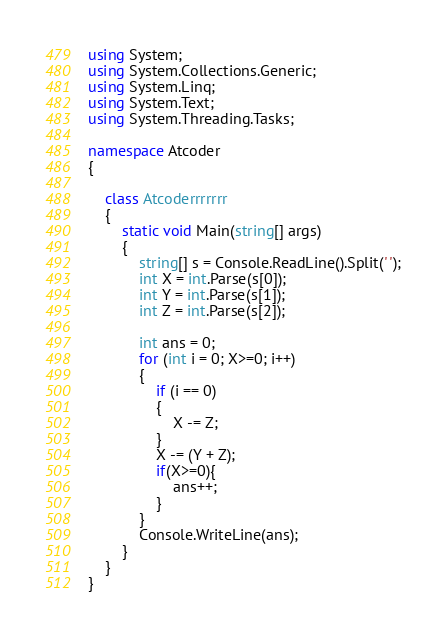<code> <loc_0><loc_0><loc_500><loc_500><_C#_>using System;
using System.Collections.Generic;
using System.Linq;
using System.Text;
using System.Threading.Tasks;

namespace Atcoder
{

    class Atcoderrrrrrr
    {
        static void Main(string[] args)
        {
            string[] s = Console.ReadLine().Split(' ');
            int X = int.Parse(s[0]);
            int Y = int.Parse(s[1]);
            int Z = int.Parse(s[2]);

            int ans = 0;
            for (int i = 0; X>=0; i++)
            {
                if (i == 0)
                {
                    X -= Z;
                }
                X -= (Y + Z);
                if(X>=0){
                    ans++;
                }
            }
            Console.WriteLine(ans);
        }
    }
}
</code> 